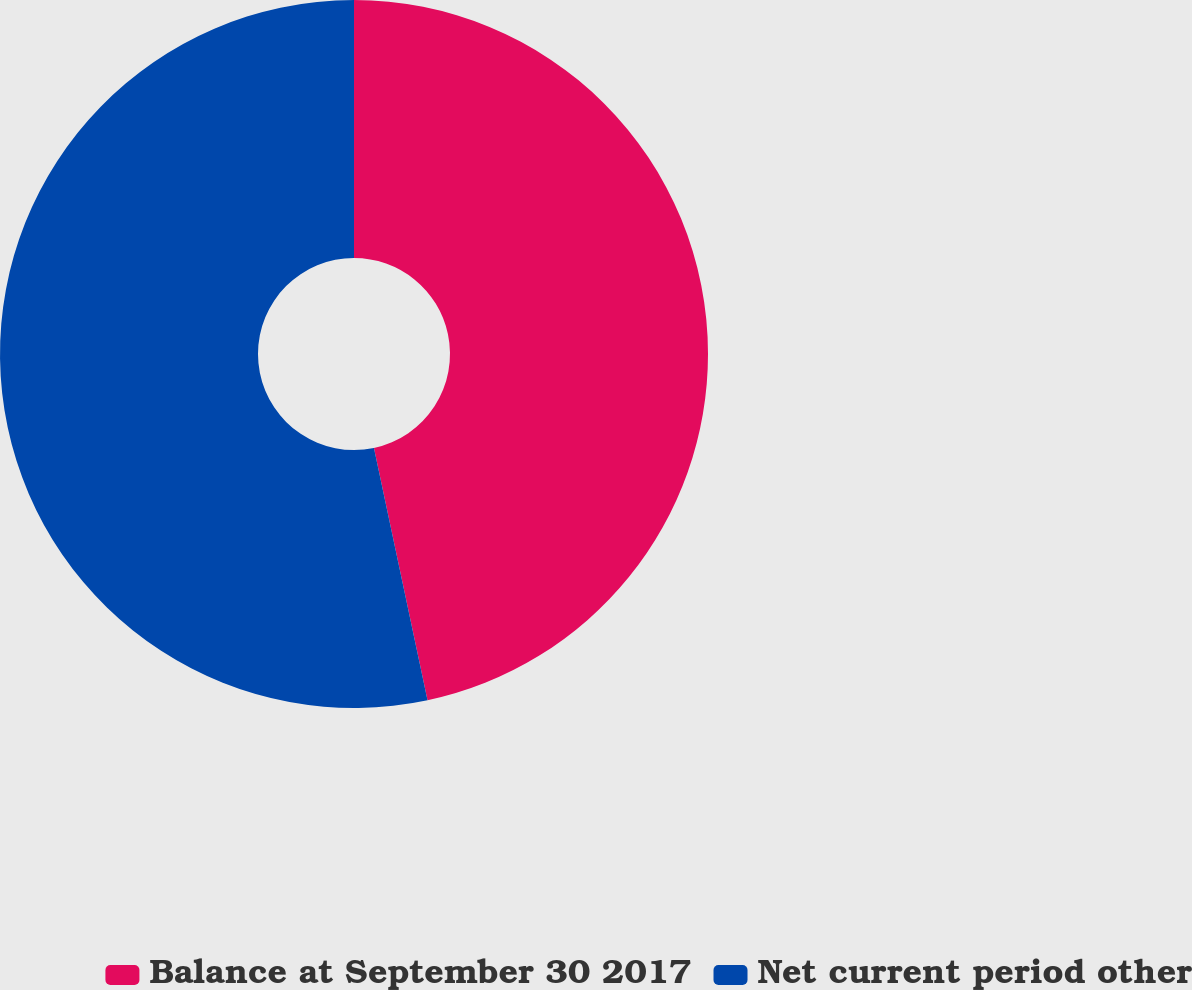<chart> <loc_0><loc_0><loc_500><loc_500><pie_chart><fcel>Balance at September 30 2017<fcel>Net current period other<nl><fcel>46.67%<fcel>53.33%<nl></chart> 